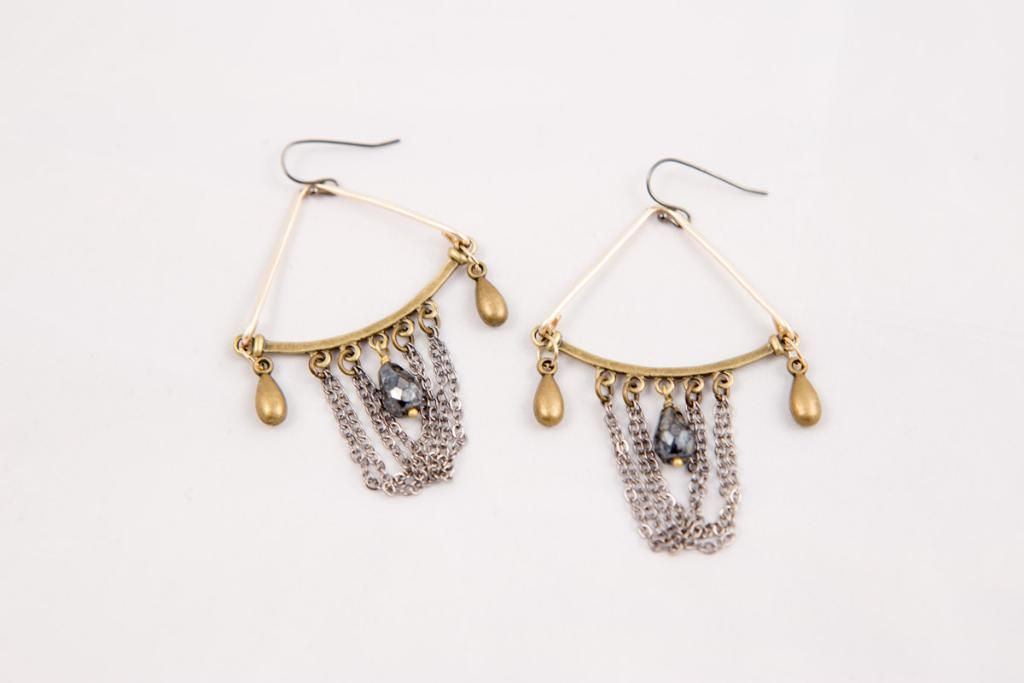What type of accessory is featured in the image? There is a pair of earrings in the image. What color is the background of the image? The background of the image is white. What type of produce is displayed on the table in the image? There is no table or produce present in the image; it only features a pair of earrings against a white background. 